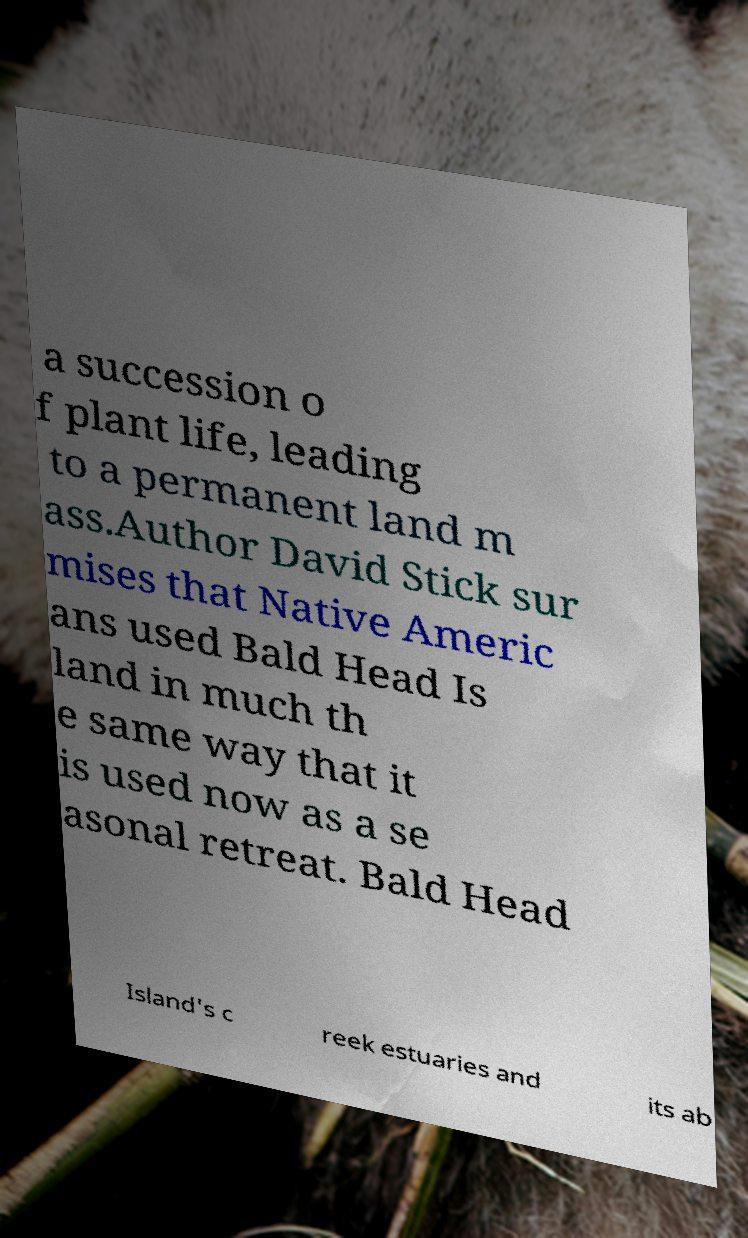Please identify and transcribe the text found in this image. a succession o f plant life, leading to a permanent land m ass.Author David Stick sur mises that Native Americ ans used Bald Head Is land in much th e same way that it is used now as a se asonal retreat. Bald Head Island's c reek estuaries and its ab 